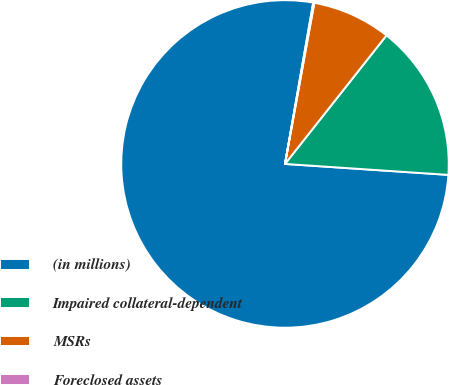Convert chart to OTSL. <chart><loc_0><loc_0><loc_500><loc_500><pie_chart><fcel>(in millions)<fcel>Impaired collateral-dependent<fcel>MSRs<fcel>Foreclosed assets<nl><fcel>76.69%<fcel>15.43%<fcel>7.77%<fcel>0.11%<nl></chart> 